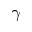Convert formula to latex. <formula><loc_0><loc_0><loc_500><loc_500>\gamma</formula> 